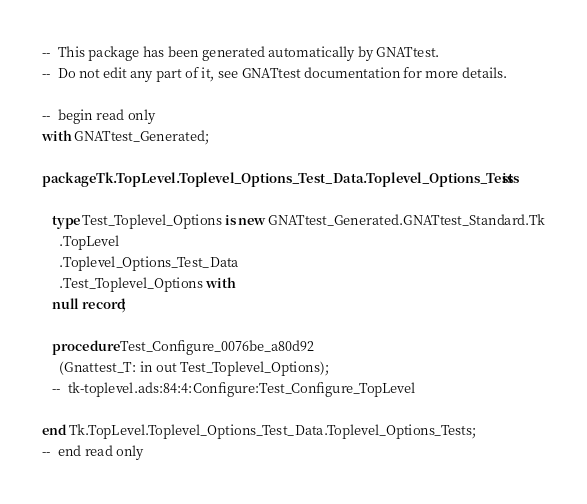Convert code to text. <code><loc_0><loc_0><loc_500><loc_500><_Ada_>--  This package has been generated automatically by GNATtest.
--  Do not edit any part of it, see GNATtest documentation for more details.

--  begin read only
with GNATtest_Generated;

package Tk.TopLevel.Toplevel_Options_Test_Data.Toplevel_Options_Tests is

   type Test_Toplevel_Options is new GNATtest_Generated.GNATtest_Standard.Tk
     .TopLevel
     .Toplevel_Options_Test_Data
     .Test_Toplevel_Options with
   null record;

   procedure Test_Configure_0076be_a80d92
     (Gnattest_T: in out Test_Toplevel_Options);
   --  tk-toplevel.ads:84:4:Configure:Test_Configure_TopLevel

end Tk.TopLevel.Toplevel_Options_Test_Data.Toplevel_Options_Tests;
--  end read only
</code> 